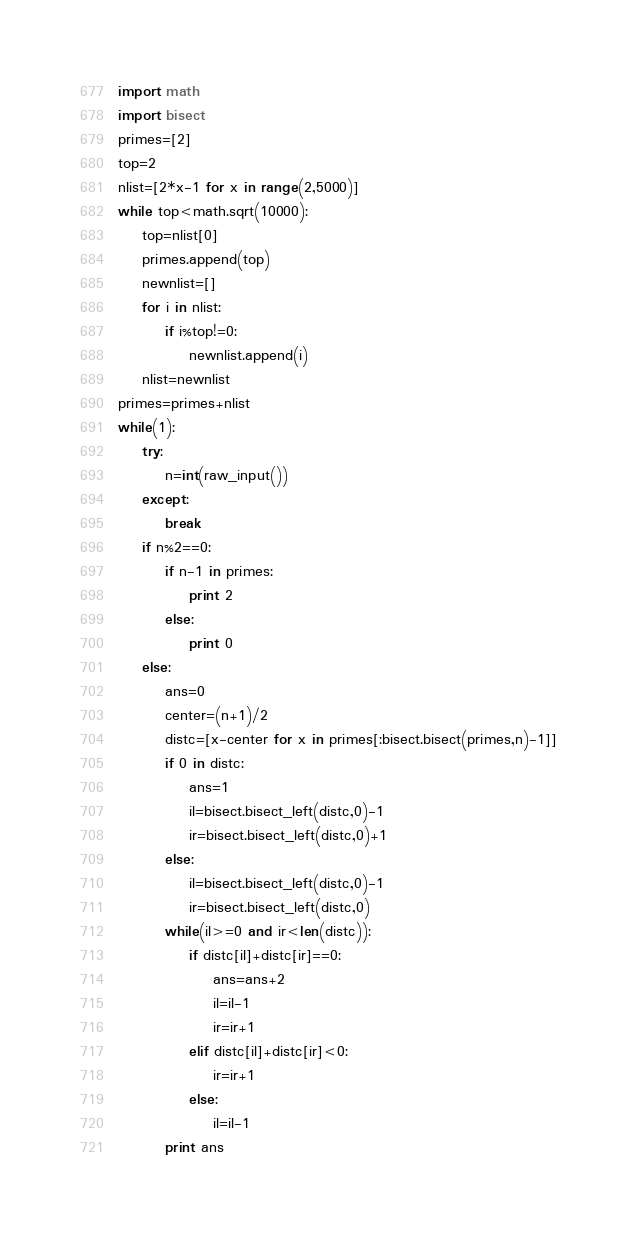<code> <loc_0><loc_0><loc_500><loc_500><_Python_>import math
import bisect
primes=[2]
top=2
nlist=[2*x-1 for x in range(2,5000)]
while top<math.sqrt(10000):
    top=nlist[0]
    primes.append(top)
    newnlist=[]
    for i in nlist:
        if i%top!=0:
            newnlist.append(i)
    nlist=newnlist
primes=primes+nlist
while(1):
    try:
        n=int(raw_input())
    except:
        break
    if n%2==0:
        if n-1 in primes:
            print 2
        else:
            print 0
    else:
        ans=0
        center=(n+1)/2
        distc=[x-center for x in primes[:bisect.bisect(primes,n)-1]]
        if 0 in distc:
            ans=1
            il=bisect.bisect_left(distc,0)-1
            ir=bisect.bisect_left(distc,0)+1
        else:
            il=bisect.bisect_left(distc,0)-1
            ir=bisect.bisect_left(distc,0)
        while(il>=0 and ir<len(distc)):
            if distc[il]+distc[ir]==0:
                ans=ans+2
                il=il-1
                ir=ir+1
            elif distc[il]+distc[ir]<0:
                ir=ir+1
            else:
                il=il-1
        print ans</code> 